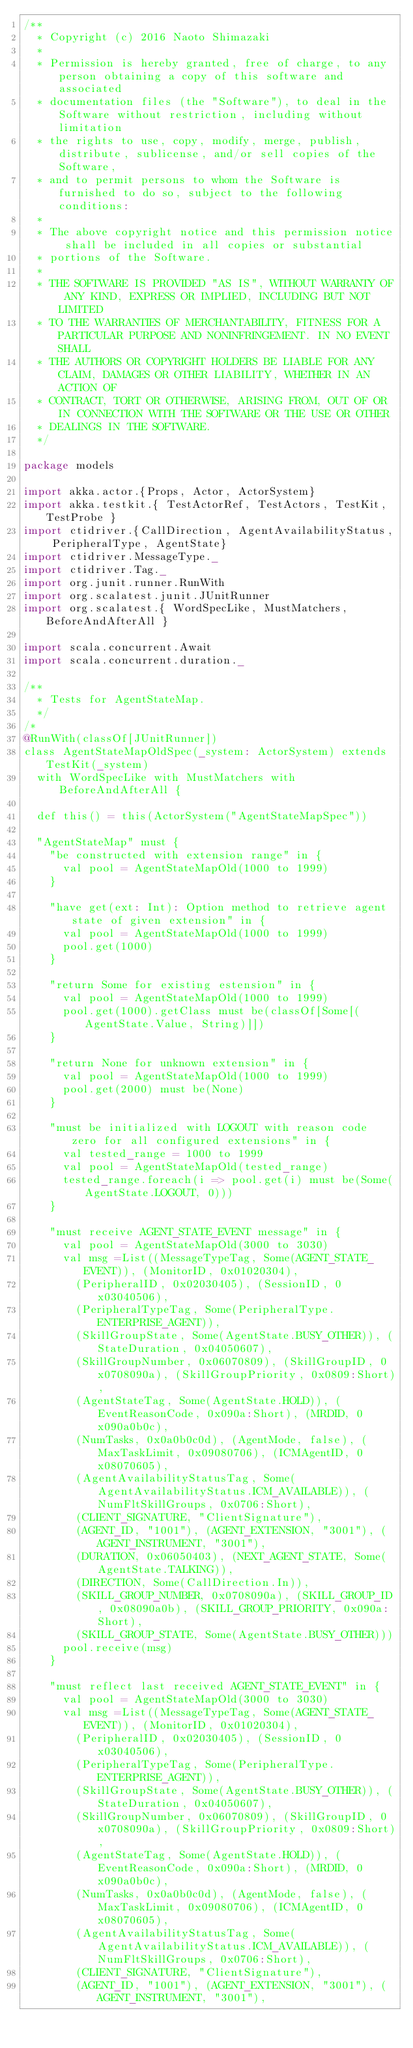<code> <loc_0><loc_0><loc_500><loc_500><_Scala_>/**
  * Copyright (c) 2016 Naoto Shimazaki
  *
  * Permission is hereby granted, free of charge, to any person obtaining a copy of this software and associated
  * documentation files (the "Software"), to deal in the Software without restriction, including without limitation
  * the rights to use, copy, modify, merge, publish, distribute, sublicense, and/or sell copies of the Software,
  * and to permit persons to whom the Software is furnished to do so, subject to the following conditions:
  *
  * The above copyright notice and this permission notice shall be included in all copies or substantial
  * portions of the Software.
  *
  * THE SOFTWARE IS PROVIDED "AS IS", WITHOUT WARRANTY OF ANY KIND, EXPRESS OR IMPLIED, INCLUDING BUT NOT LIMITED
  * TO THE WARRANTIES OF MERCHANTABILITY, FITNESS FOR A PARTICULAR PURPOSE AND NONINFRINGEMENT. IN NO EVENT SHALL
  * THE AUTHORS OR COPYRIGHT HOLDERS BE LIABLE FOR ANY CLAIM, DAMAGES OR OTHER LIABILITY, WHETHER IN AN ACTION OF
  * CONTRACT, TORT OR OTHERWISE, ARISING FROM, OUT OF OR IN CONNECTION WITH THE SOFTWARE OR THE USE OR OTHER
  * DEALINGS IN THE SOFTWARE.
  */

package models

import akka.actor.{Props, Actor, ActorSystem}
import akka.testkit.{ TestActorRef, TestActors, TestKit, TestProbe }
import ctidriver.{CallDirection, AgentAvailabilityStatus, PeripheralType, AgentState}
import ctidriver.MessageType._
import ctidriver.Tag._
import org.junit.runner.RunWith
import org.scalatest.junit.JUnitRunner
import org.scalatest.{ WordSpecLike, MustMatchers, BeforeAndAfterAll }

import scala.concurrent.Await
import scala.concurrent.duration._

/**
  * Tests for AgentStateMap.
  */
/*
@RunWith(classOf[JUnitRunner])
class AgentStateMapOldSpec(_system: ActorSystem) extends TestKit(_system)
  with WordSpecLike with MustMatchers with BeforeAndAfterAll {

  def this() = this(ActorSystem("AgentStateMapSpec"))

  "AgentStateMap" must {
    "be constructed with extension range" in {
      val pool = AgentStateMapOld(1000 to 1999)
    }

    "have get(ext: Int): Option method to retrieve agent state of given extension" in {
      val pool = AgentStateMapOld(1000 to 1999)
      pool.get(1000)
    }

    "return Some for existing estension" in {
      val pool = AgentStateMapOld(1000 to 1999)
      pool.get(1000).getClass must be(classOf[Some[(AgentState.Value, String)]])
    }

    "return None for unknown extension" in {
      val pool = AgentStateMapOld(1000 to 1999)
      pool.get(2000) must be(None)
    }

    "must be initialized with LOGOUT with reason code zero for all configured extensions" in {
      val tested_range = 1000 to 1999
      val pool = AgentStateMapOld(tested_range)
      tested_range.foreach(i => pool.get(i) must be(Some(AgentState.LOGOUT, 0)))
    }

    "must receive AGENT_STATE_EVENT message" in {
      val pool = AgentStateMapOld(3000 to 3030)
      val msg =List((MessageTypeTag, Some(AGENT_STATE_EVENT)), (MonitorID, 0x01020304),
        (PeripheralID, 0x02030405), (SessionID, 0x03040506),
        (PeripheralTypeTag, Some(PeripheralType.ENTERPRISE_AGENT)),
        (SkillGroupState, Some(AgentState.BUSY_OTHER)), (StateDuration, 0x04050607),
        (SkillGroupNumber, 0x06070809), (SkillGroupID, 0x0708090a), (SkillGroupPriority, 0x0809:Short),
        (AgentStateTag, Some(AgentState.HOLD)), (EventReasonCode, 0x090a:Short), (MRDID, 0x090a0b0c),
        (NumTasks, 0x0a0b0c0d), (AgentMode, false), (MaxTaskLimit, 0x09080706), (ICMAgentID, 0x08070605),
        (AgentAvailabilityStatusTag, Some(AgentAvailabilityStatus.ICM_AVAILABLE)), (NumFltSkillGroups, 0x0706:Short),
        (CLIENT_SIGNATURE, "ClientSignature"),
        (AGENT_ID, "1001"), (AGENT_EXTENSION, "3001"), (AGENT_INSTRUMENT, "3001"),
        (DURATION, 0x06050403), (NEXT_AGENT_STATE, Some(AgentState.TALKING)),
        (DIRECTION, Some(CallDirection.In)),
        (SKILL_GROUP_NUMBER, 0x0708090a), (SKILL_GROUP_ID, 0x08090a0b), (SKILL_GROUP_PRIORITY, 0x090a:Short),
        (SKILL_GROUP_STATE, Some(AgentState.BUSY_OTHER)))
      pool.receive(msg)
    }

    "must reflect last received AGENT_STATE_EVENT" in {
      val pool = AgentStateMapOld(3000 to 3030)
      val msg =List((MessageTypeTag, Some(AGENT_STATE_EVENT)), (MonitorID, 0x01020304),
        (PeripheralID, 0x02030405), (SessionID, 0x03040506),
        (PeripheralTypeTag, Some(PeripheralType.ENTERPRISE_AGENT)),
        (SkillGroupState, Some(AgentState.BUSY_OTHER)), (StateDuration, 0x04050607),
        (SkillGroupNumber, 0x06070809), (SkillGroupID, 0x0708090a), (SkillGroupPriority, 0x0809:Short),
        (AgentStateTag, Some(AgentState.HOLD)), (EventReasonCode, 0x090a:Short), (MRDID, 0x090a0b0c),
        (NumTasks, 0x0a0b0c0d), (AgentMode, false), (MaxTaskLimit, 0x09080706), (ICMAgentID, 0x08070605),
        (AgentAvailabilityStatusTag, Some(AgentAvailabilityStatus.ICM_AVAILABLE)), (NumFltSkillGroups, 0x0706:Short),
        (CLIENT_SIGNATURE, "ClientSignature"),
        (AGENT_ID, "1001"), (AGENT_EXTENSION, "3001"), (AGENT_INSTRUMENT, "3001"),</code> 